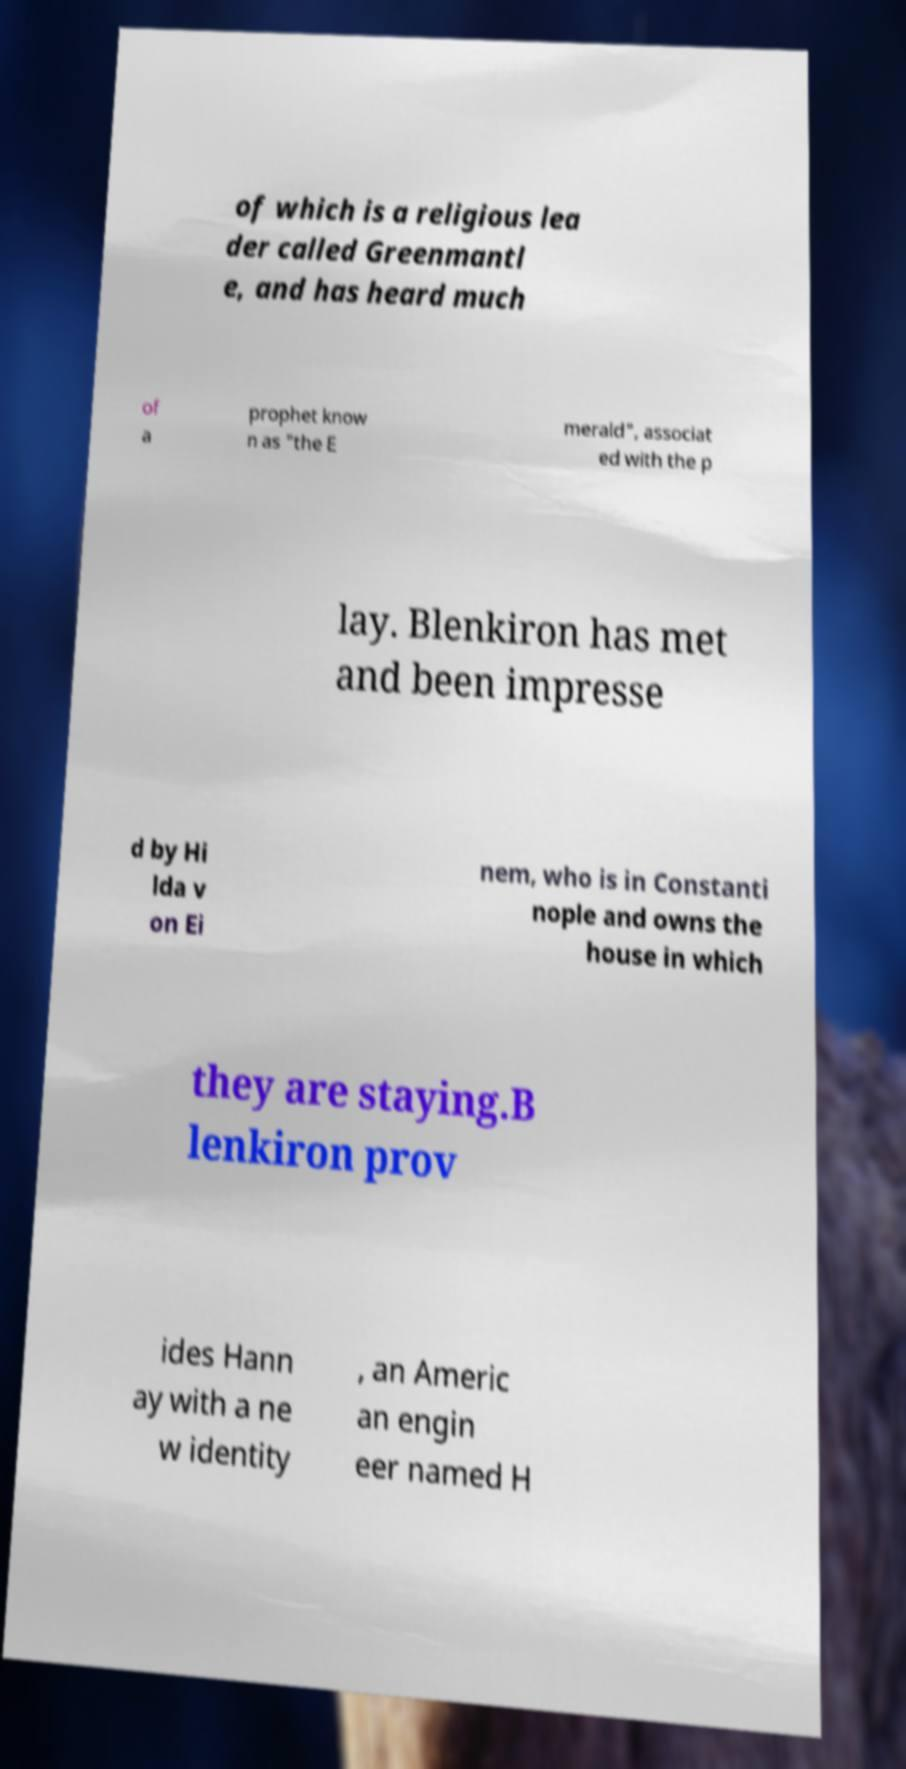Please identify and transcribe the text found in this image. of which is a religious lea der called Greenmantl e, and has heard much of a prophet know n as "the E merald", associat ed with the p lay. Blenkiron has met and been impresse d by Hi lda v on Ei nem, who is in Constanti nople and owns the house in which they are staying.B lenkiron prov ides Hann ay with a ne w identity , an Americ an engin eer named H 